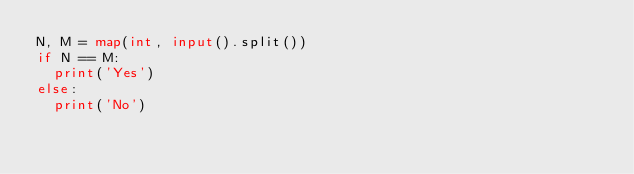Convert code to text. <code><loc_0><loc_0><loc_500><loc_500><_Python_>N, M = map(int, input().split())
if N == M:
  print('Yes')
else:
  print('No')</code> 